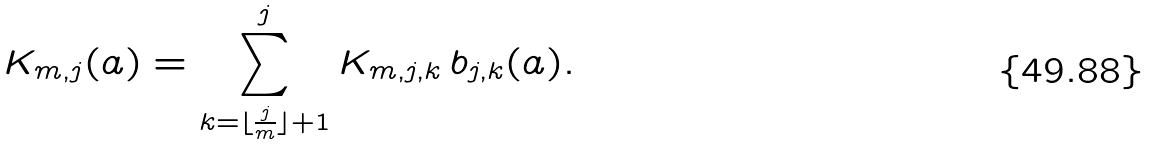Convert formula to latex. <formula><loc_0><loc_0><loc_500><loc_500>K _ { m , j } ( { a } ) = \sum _ { k = \lfloor \frac { j } { m } \rfloor + 1 } ^ { j } K _ { m , j , k } \, b _ { j , k } ( { a } ) .</formula> 